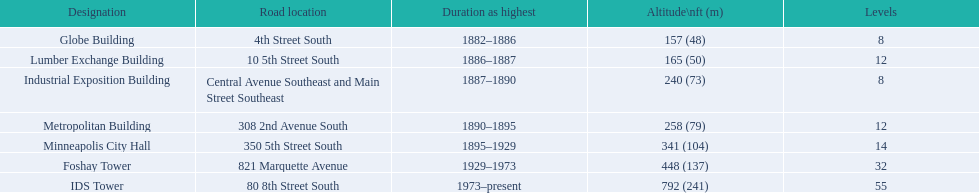What are the heights of the buildings? 157 (48), 165 (50), 240 (73), 258 (79), 341 (104), 448 (137), 792 (241). What building is 240 ft tall? Industrial Exposition Building. 